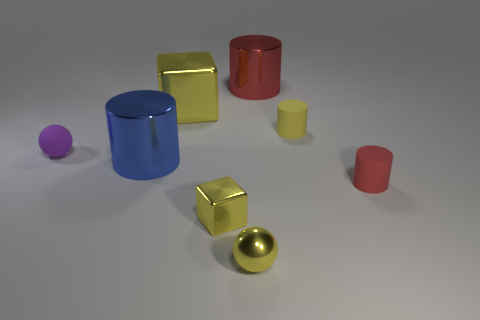Add 1 red matte things. How many objects exist? 9 Subtract all blocks. How many objects are left? 6 Add 1 tiny red things. How many tiny red things exist? 2 Subtract 0 gray cylinders. How many objects are left? 8 Subtract all cubes. Subtract all small red rubber cylinders. How many objects are left? 5 Add 1 purple rubber things. How many purple rubber things are left? 2 